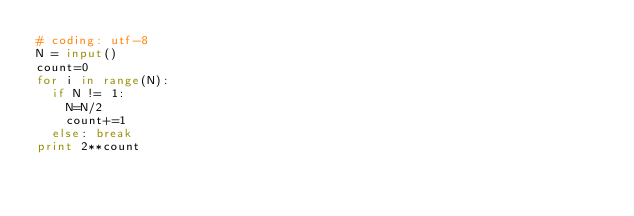Convert code to text. <code><loc_0><loc_0><loc_500><loc_500><_Python_># coding: utf-8
N = input()
count=0
for i in range(N):
  if N != 1:
    N=N/2
    count+=1
  else: break
print 2**count</code> 